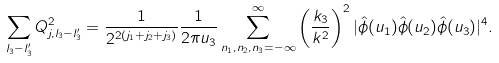<formula> <loc_0><loc_0><loc_500><loc_500>\sum _ { l _ { 3 } - l ^ { \prime } _ { 3 } } Q ^ { 2 } _ { { j } , l _ { 3 } - l ^ { \prime } _ { 3 } } = \frac { 1 } { 2 ^ { 2 ( j _ { 1 } + j _ { 2 } + j _ { 3 } ) } } \frac { 1 } { 2 \pi u _ { 3 } } \sum _ { n _ { 1 } , n _ { 2 } , n _ { 3 } = - \infty } ^ { \infty } \left ( \frac { k _ { 3 } } { k ^ { 2 } } \right ) ^ { 2 } | \hat { \phi } ( u _ { 1 } ) \hat { \phi } ( u _ { 2 } ) \hat { \phi } ( u _ { 3 } ) | ^ { 4 } .</formula> 